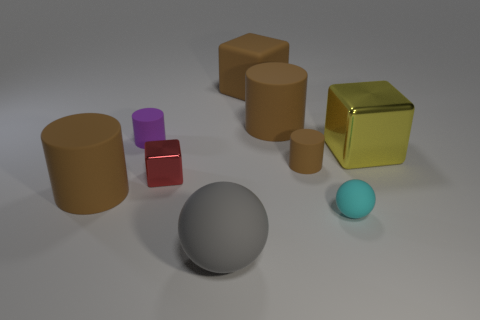There is a big object that is on the right side of the big rubber cylinder right of the red metallic cube; what is it made of?
Offer a very short reply. Metal. How many other objects are there of the same material as the big gray ball?
Your answer should be very brief. 6. Is the tiny metal object the same shape as the yellow metallic object?
Keep it short and to the point. Yes. What is the size of the sphere that is behind the gray sphere?
Ensure brevity in your answer.  Small. Is the size of the matte cube the same as the rubber sphere that is on the left side of the small cyan sphere?
Provide a short and direct response. Yes. Is the number of large brown things that are to the right of the cyan matte ball less than the number of small red cubes?
Offer a very short reply. Yes. What is the material of the yellow thing that is the same shape as the tiny red metallic object?
Keep it short and to the point. Metal. The brown rubber thing that is both to the right of the purple thing and in front of the purple matte cylinder has what shape?
Keep it short and to the point. Cylinder. What shape is the tiny purple thing that is the same material as the big gray thing?
Offer a very short reply. Cylinder. What is the material of the cube that is left of the large gray object?
Offer a terse response. Metal. 